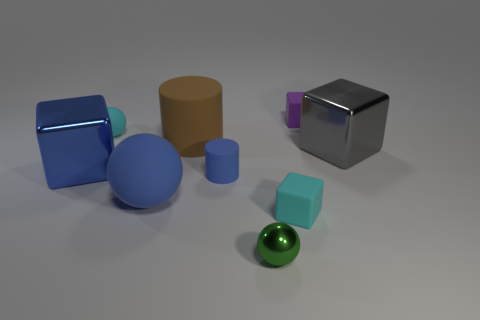Subtract all yellow blocks. Subtract all blue balls. How many blocks are left? 4 Add 1 large blocks. How many objects exist? 10 Subtract all blocks. How many objects are left? 5 Add 1 large gray objects. How many large gray objects are left? 2 Add 1 tiny rubber cylinders. How many tiny rubber cylinders exist? 2 Subtract 1 blue cylinders. How many objects are left? 8 Subtract all big things. Subtract all tiny green things. How many objects are left? 4 